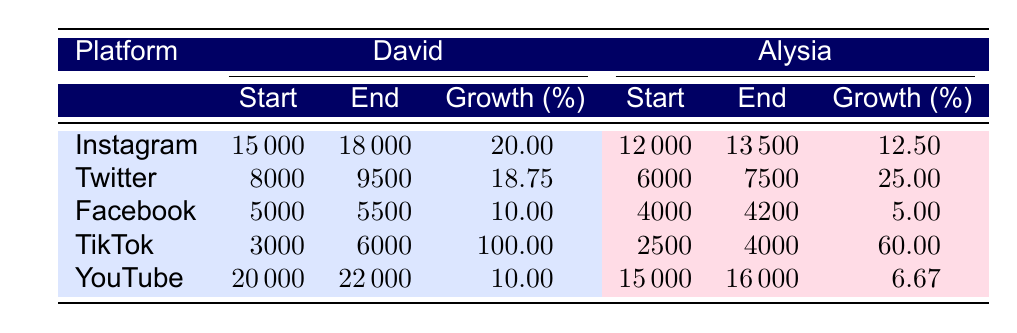What was David's starting follower count on Instagram? Looking at the table, the 'Start' value for David on Instagram is shown as 15000.
Answer: 15000 What is the percentage growth of Alysia's followers on Twitter? In the table, the Growth percentage for Alysia on Twitter is listed as 25.00.
Answer: 25.00 Which platform showed the highest percentage growth for David? The Growth percentage for David on TikTok is 100.00, which is the highest value compared to other platforms listed in the table.
Answer: TikTok Did Alysia have more followers than David on Facebook at the end? Alysia ended with 4200 followers, while David ended with 5500, which means David had more followers than Alysia on Facebook.
Answer: No What is the average growth percentage of David across all platforms? To find the average, sum all the growth percentages for David: (20 + 18.75 + 10 + 100 + 10)/5 = 31.75. Thus, the average growth is 31.75.
Answer: 31.75 What was Alysia's follower count on TikTok before the growth? According to the table, Alysia started with 2500 followers on TikTok.
Answer: 2500 What platform did Alysia experience the least growth percentage? The Growth percentage for Alysia on Facebook is 5.00, which is the lowest compared with other platforms in the table.
Answer: Facebook If we combine the starting follower counts for both David and Alysia on Instagram, what is the total? The starting values are David with 15000 and Alysia with 12000. Adding these gives 15000 + 12000 = 27000.
Answer: 27000 What is the difference between David's starting and ending follower count on YouTube? The starting count for David on YouTube is 20000 and the ending count is 22000. The difference is 22000 - 20000 = 2000.
Answer: 2000 